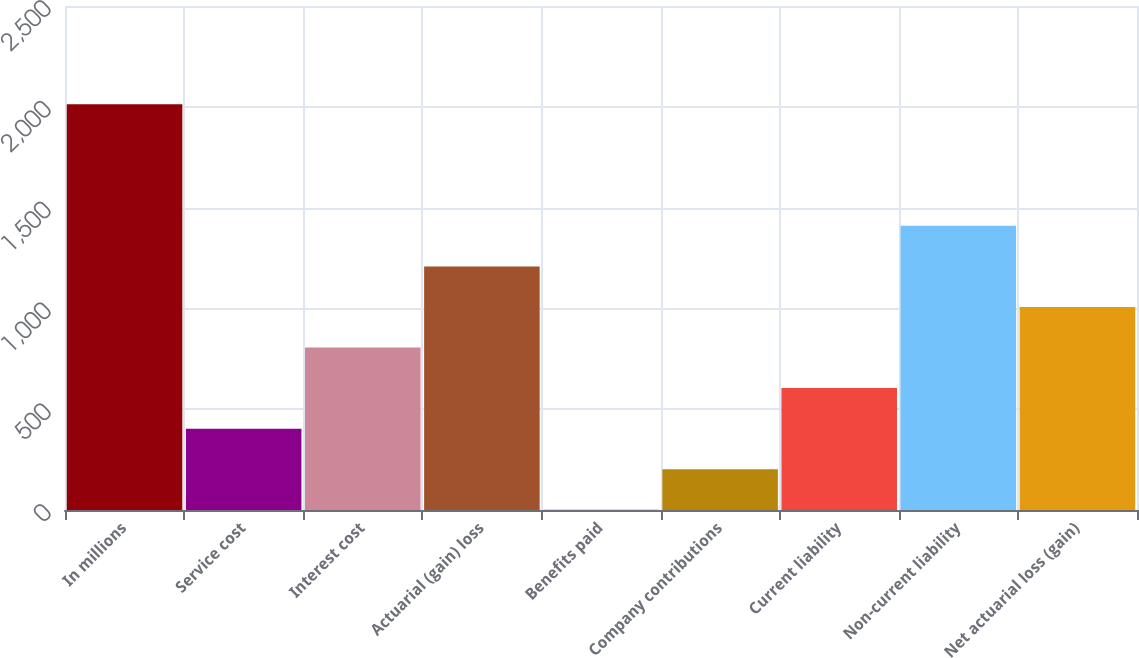<chart> <loc_0><loc_0><loc_500><loc_500><bar_chart><fcel>In millions<fcel>Service cost<fcel>Interest cost<fcel>Actuarial (gain) loss<fcel>Benefits paid<fcel>Company contributions<fcel>Current liability<fcel>Non-current liability<fcel>Net actuarial loss (gain)<nl><fcel>2013<fcel>403.4<fcel>805.8<fcel>1208.2<fcel>1<fcel>202.2<fcel>604.6<fcel>1409.4<fcel>1007<nl></chart> 